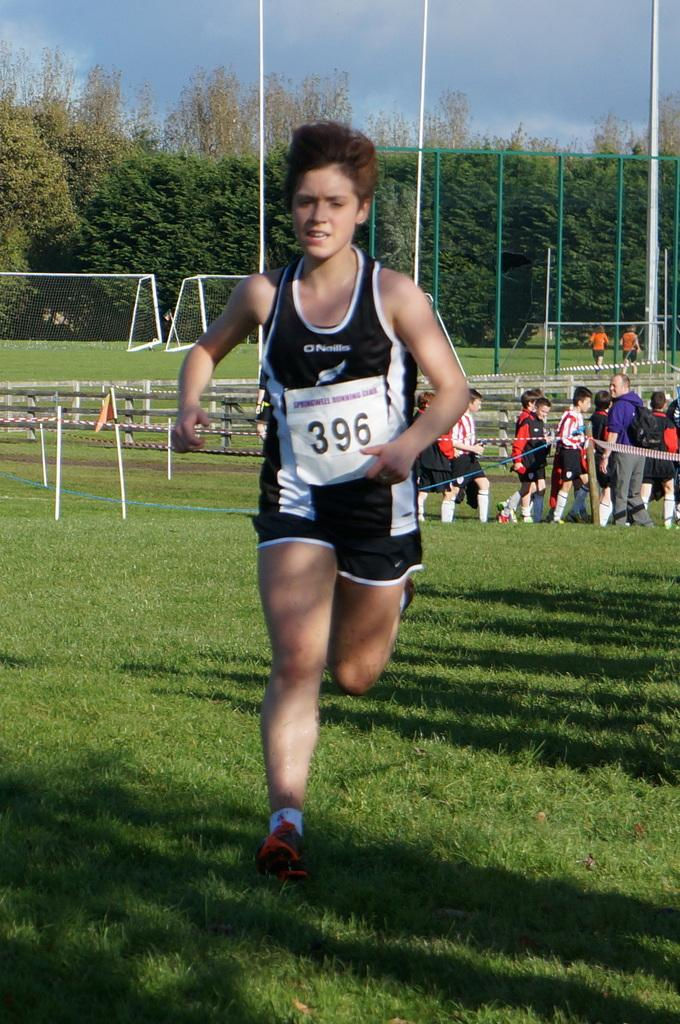What is the woman in the image doing? The woman is running in the image. What type of surface is the woman running on? There is grass on the ground in the image. Can you describe the people in the image? There are people standing in the image. What can be seen in the background of the image? There are trees visible in the image. How would you describe the sky in the image? The sky is blue and cloudy in the image. What objects are present in the image that are not related to the people or the sky? There are poles in the image. What type of thread is being used by the woman to play in the image? There is no thread or playing activity present in the image; the woman is running. What kind of club is being held by the people in the image? There is no club or club-related activity present in the image; the people are standing. 